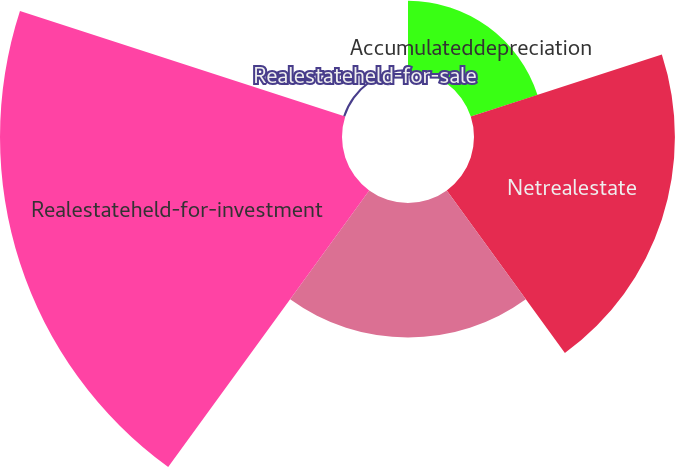<chart> <loc_0><loc_0><loc_500><loc_500><pie_chart><fcel>Accumulateddepreciation<fcel>Netrealestate<fcel>Unnamed: 2<fcel>Realestateheld-for-investment<fcel>Realestateheld-for-sale<nl><fcel>9.36%<fcel>26.8%<fcel>17.94%<fcel>45.62%<fcel>0.28%<nl></chart> 